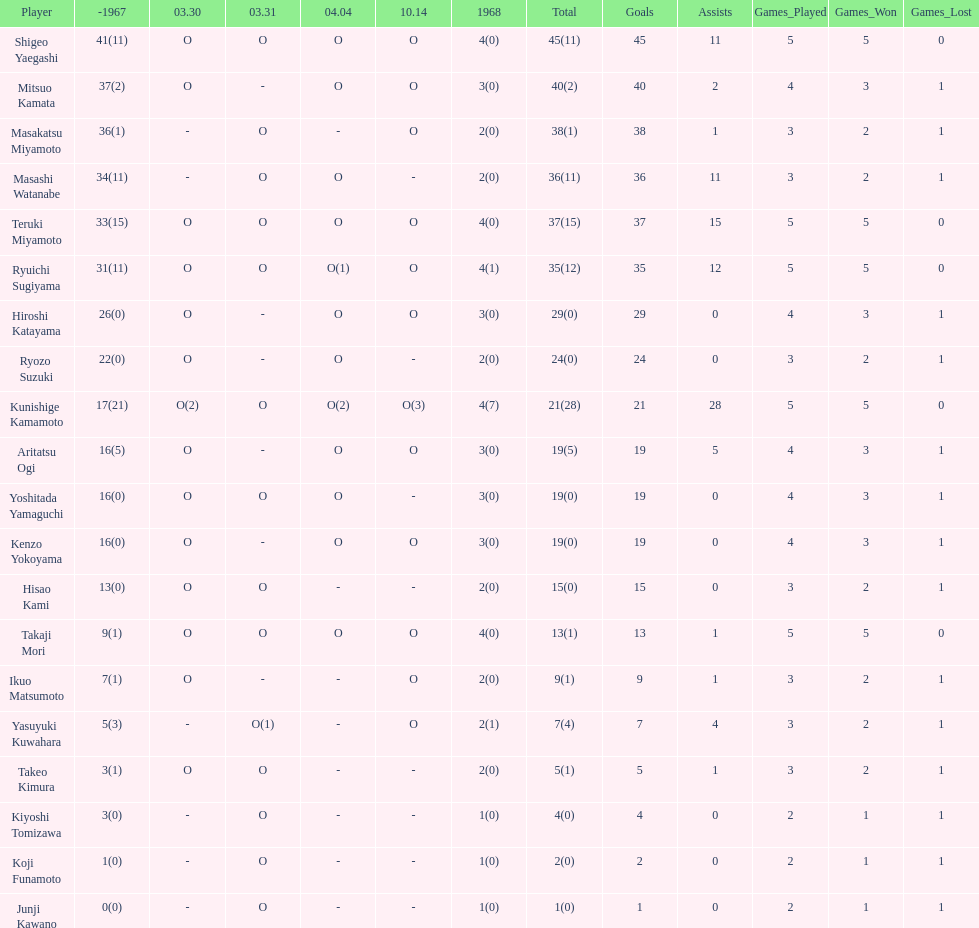How many total did mitsuo kamata have? 40(2). 